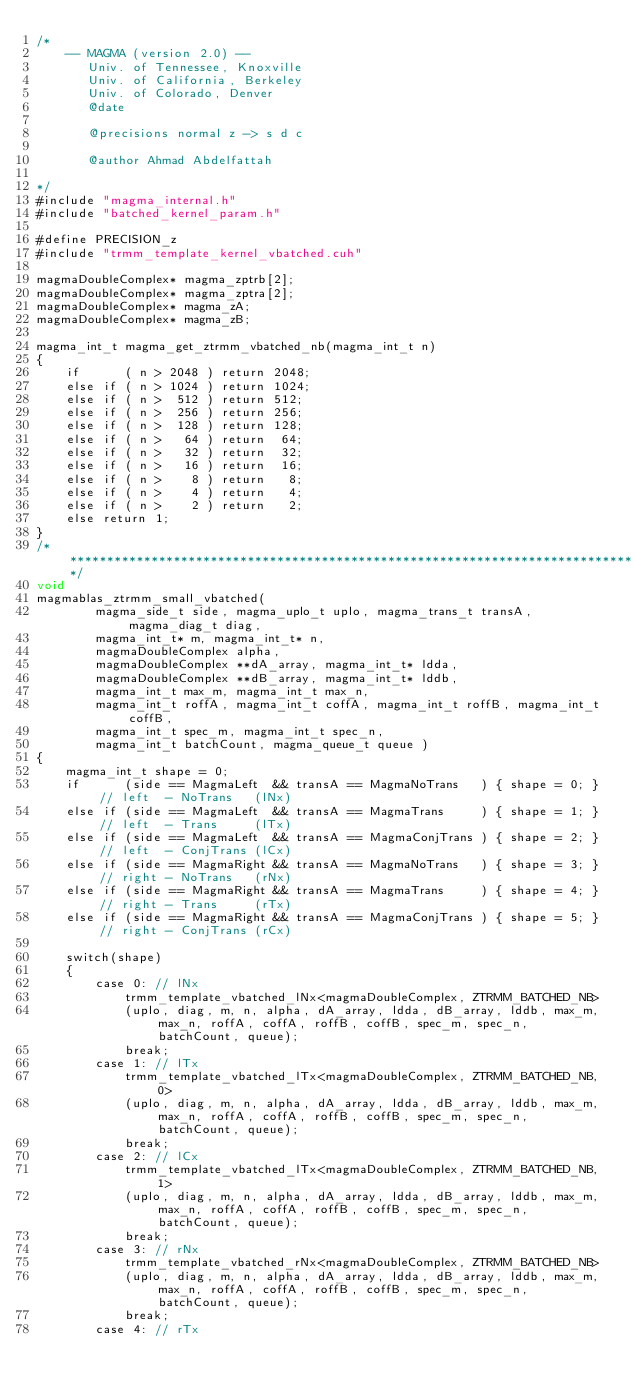<code> <loc_0><loc_0><loc_500><loc_500><_Cuda_>/*
    -- MAGMA (version 2.0) --
       Univ. of Tennessee, Knoxville
       Univ. of California, Berkeley
       Univ. of Colorado, Denver
       @date

       @precisions normal z -> s d c

       @author Ahmad Abdelfattah
       
*/
#include "magma_internal.h"
#include "batched_kernel_param.h"

#define PRECISION_z
#include "trmm_template_kernel_vbatched.cuh"

magmaDoubleComplex* magma_zptrb[2];
magmaDoubleComplex* magma_zptra[2];
magmaDoubleComplex* magma_zA;
magmaDoubleComplex* magma_zB;

magma_int_t magma_get_ztrmm_vbatched_nb(magma_int_t n)
{
    if      ( n > 2048 ) return 2048;
    else if ( n > 1024 ) return 1024;
    else if ( n >  512 ) return 512;
    else if ( n >  256 ) return 256;
    else if ( n >  128 ) return 128;
    else if ( n >   64 ) return  64;
    else if ( n >   32 ) return  32;
    else if ( n >   16 ) return  16;
    else if ( n >    8 ) return   8;
    else if ( n >    4 ) return   4;
    else if ( n >    2 ) return   2;
    else return 1;
}
/******************************************************************************/
void
magmablas_ztrmm_small_vbatched(
        magma_side_t side, magma_uplo_t uplo, magma_trans_t transA, magma_diag_t diag, 
        magma_int_t* m, magma_int_t* n, 
        magmaDoubleComplex alpha, 
        magmaDoubleComplex **dA_array, magma_int_t* ldda,
        magmaDoubleComplex **dB_array, magma_int_t* lddb, 
        magma_int_t max_m, magma_int_t max_n, 
        magma_int_t roffA, magma_int_t coffA, magma_int_t roffB, magma_int_t coffB, 
        magma_int_t spec_m, magma_int_t spec_n, 
        magma_int_t batchCount, magma_queue_t queue )
{
    magma_int_t shape = 0;
    if      (side == MagmaLeft  && transA == MagmaNoTrans   ) { shape = 0; } // left  - NoTrans   (lNx)
    else if (side == MagmaLeft  && transA == MagmaTrans     ) { shape = 1; } // left  - Trans     (lTx)
    else if (side == MagmaLeft  && transA == MagmaConjTrans ) { shape = 2; } // left  - ConjTrans (lCx)
    else if (side == MagmaRight && transA == MagmaNoTrans   ) { shape = 3; } // right - NoTrans   (rNx)
    else if (side == MagmaRight && transA == MagmaTrans     ) { shape = 4; } // right - Trans     (rTx)
    else if (side == MagmaRight && transA == MagmaConjTrans ) { shape = 5; } // right - ConjTrans (rCx)
    
    switch(shape)
    {
        case 0: // lNx
            trmm_template_vbatched_lNx<magmaDoubleComplex, ZTRMM_BATCHED_NB>
            (uplo, diag, m, n, alpha, dA_array, ldda, dB_array, lddb, max_m, max_n, roffA, coffA, roffB, coffB, spec_m, spec_n, batchCount, queue);
            break;
        case 1: // lTx
            trmm_template_vbatched_lTx<magmaDoubleComplex, ZTRMM_BATCHED_NB, 0>
            (uplo, diag, m, n, alpha, dA_array, ldda, dB_array, lddb, max_m, max_n, roffA, coffA, roffB, coffB, spec_m, spec_n, batchCount, queue);
            break;
        case 2: // lCx
            trmm_template_vbatched_lTx<magmaDoubleComplex, ZTRMM_BATCHED_NB, 1>
            (uplo, diag, m, n, alpha, dA_array, ldda, dB_array, lddb, max_m, max_n, roffA, coffA, roffB, coffB, spec_m, spec_n, batchCount, queue);
            break;
        case 3: // rNx
            trmm_template_vbatched_rNx<magmaDoubleComplex, ZTRMM_BATCHED_NB>
            (uplo, diag, m, n, alpha, dA_array, ldda, dB_array, lddb, max_m, max_n, roffA, coffA, roffB, coffB, spec_m, spec_n, batchCount, queue);
            break;
        case 4: // rTx</code> 